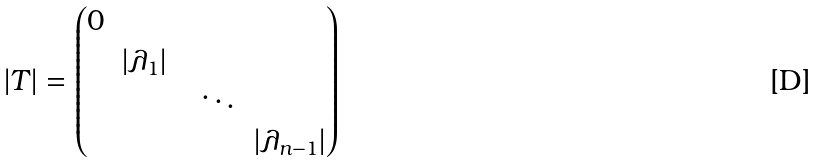<formula> <loc_0><loc_0><loc_500><loc_500>| T | = \begin{pmatrix} 0 & & & & \\ & | \lambda _ { 1 } | & & & \\ & & & \ddots & \\ & & & & | \lambda _ { n - 1 } | \\ \end{pmatrix}</formula> 